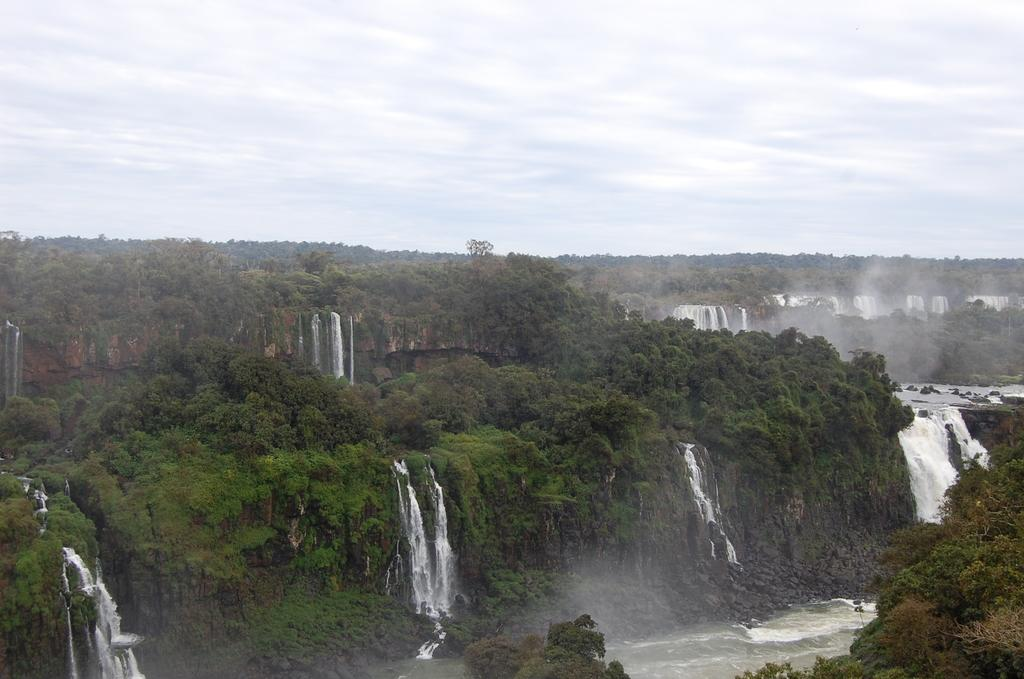What natural feature can be seen in the image? There are waterfalls in the image. What type of vegetation is present on the mountains in the image? There are trees on the mountains in the image. Where are the mountains located in the image? The mountains are at the bottom of the image. What is visible at the top of the image? There is a sky visible at the top of the image. What type of fruit is hanging from the trees on the mountains in the image? There is no fruit visible on the trees in the image; only trees are present. 